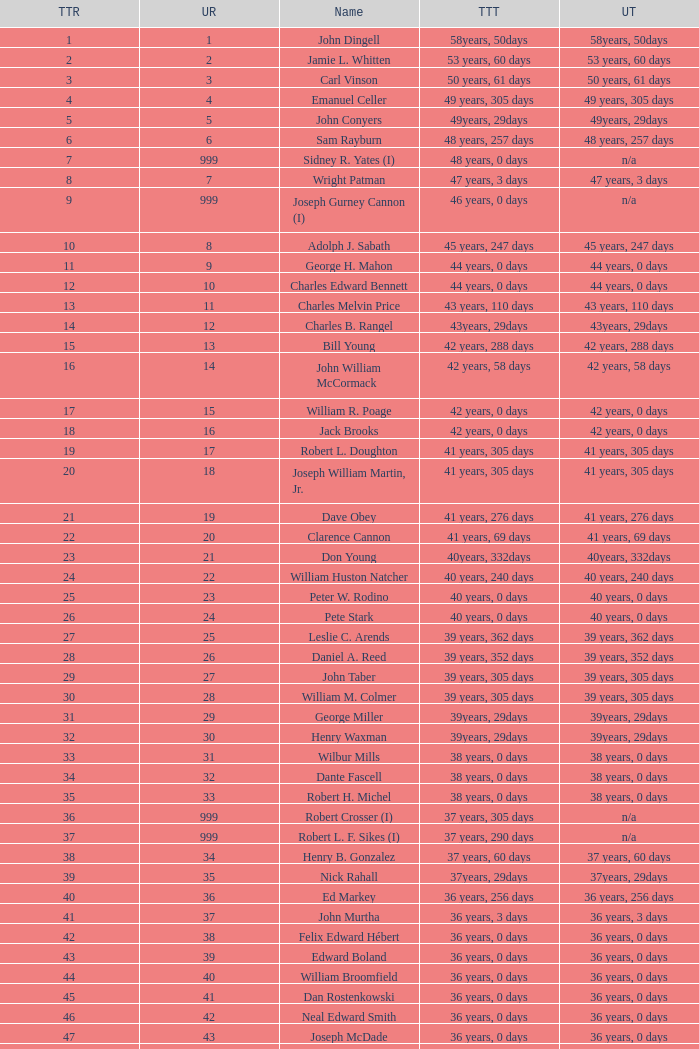How many uninterrupted ranks does john dingell have? 1.0. 